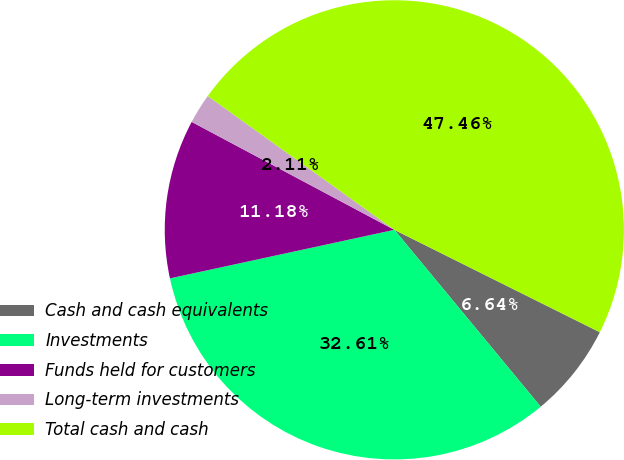Convert chart. <chart><loc_0><loc_0><loc_500><loc_500><pie_chart><fcel>Cash and cash equivalents<fcel>Investments<fcel>Funds held for customers<fcel>Long-term investments<fcel>Total cash and cash<nl><fcel>6.64%<fcel>32.61%<fcel>11.18%<fcel>2.11%<fcel>47.46%<nl></chart> 